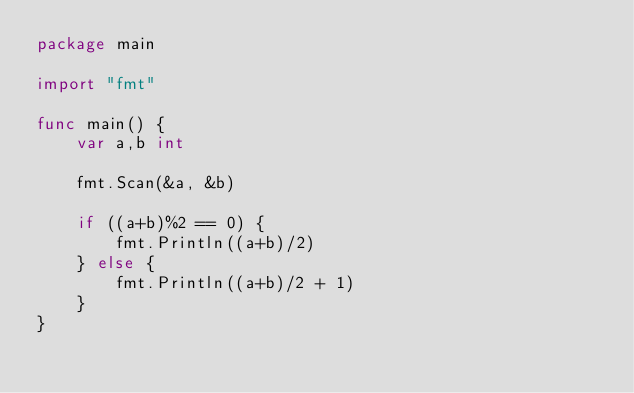Convert code to text. <code><loc_0><loc_0><loc_500><loc_500><_Go_>package main

import "fmt"

func main() {
    var a,b int

    fmt.Scan(&a, &b)

    if ((a+b)%2 == 0) {
        fmt.Println((a+b)/2)
    } else {
        fmt.Println((a+b)/2 + 1)
    }
}</code> 